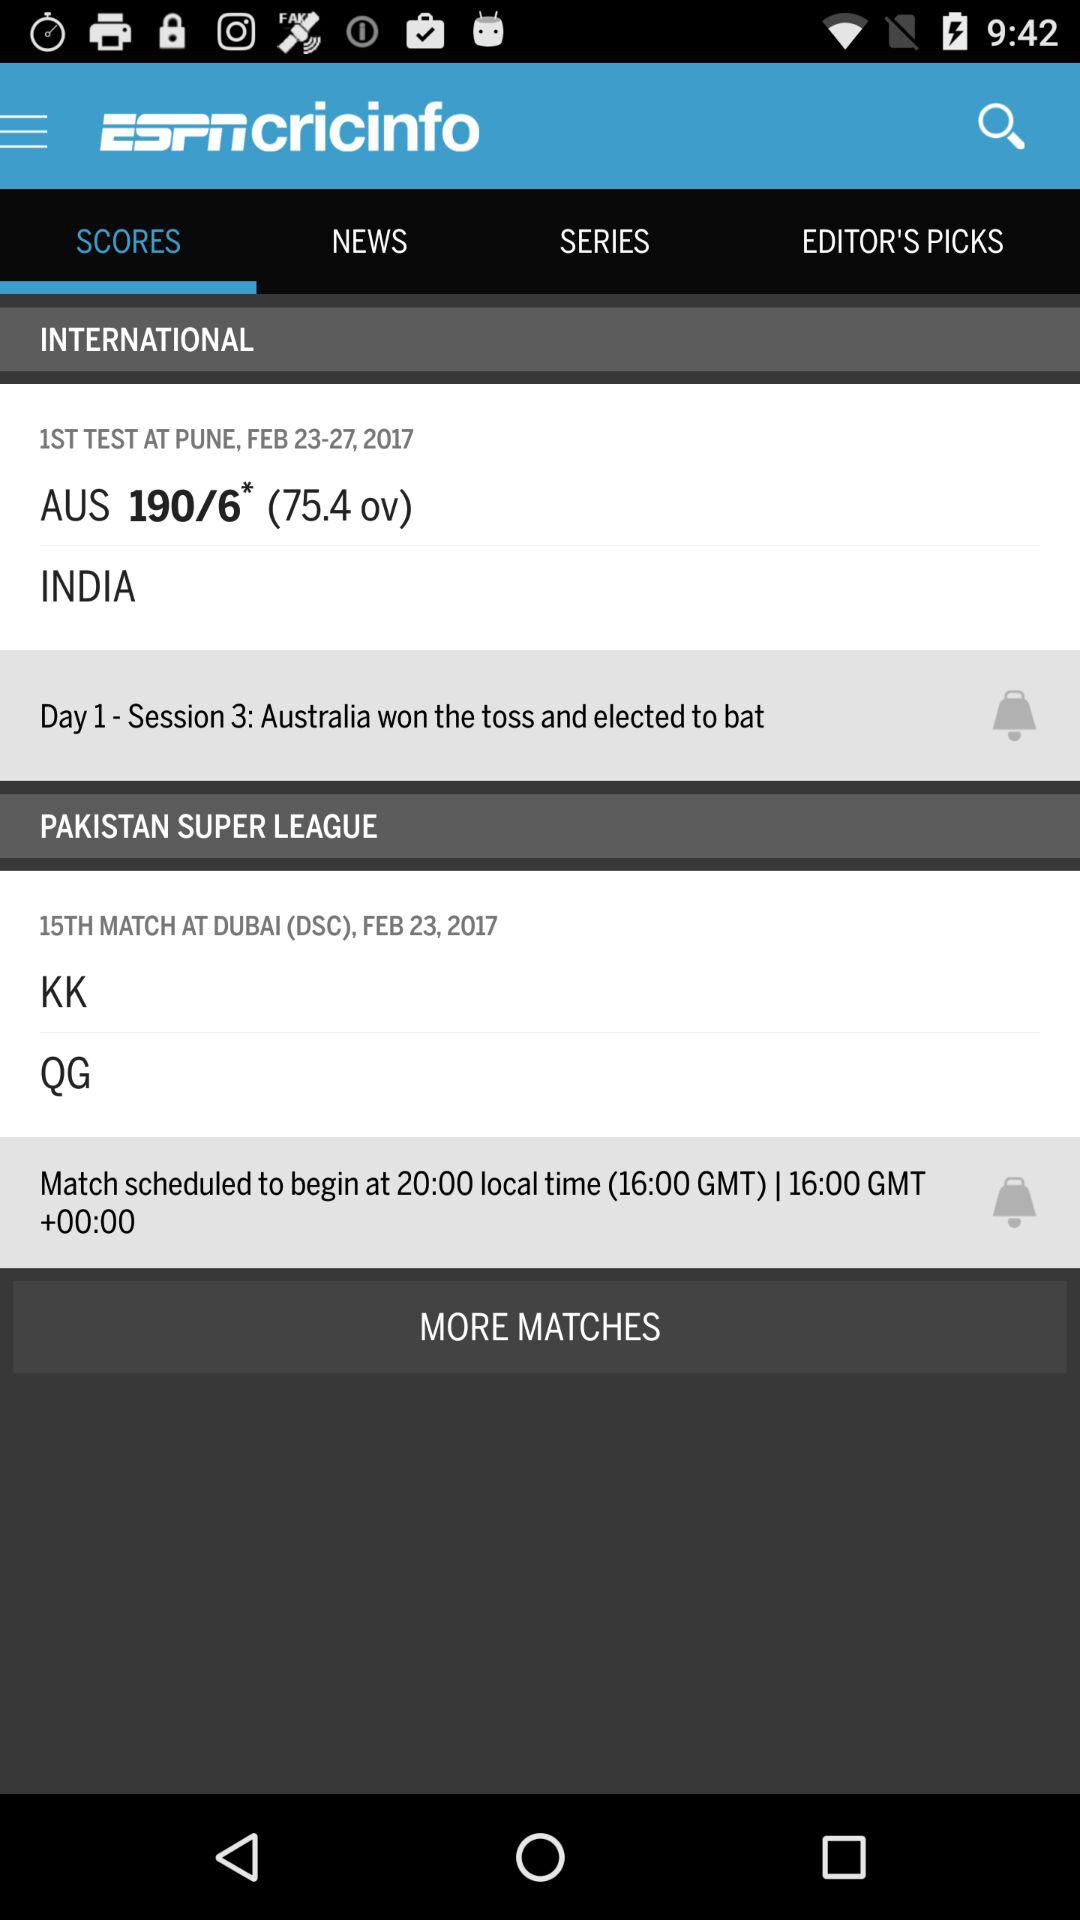On which date is the match between KK and QG scheduled? The date is February 23, 2017. 